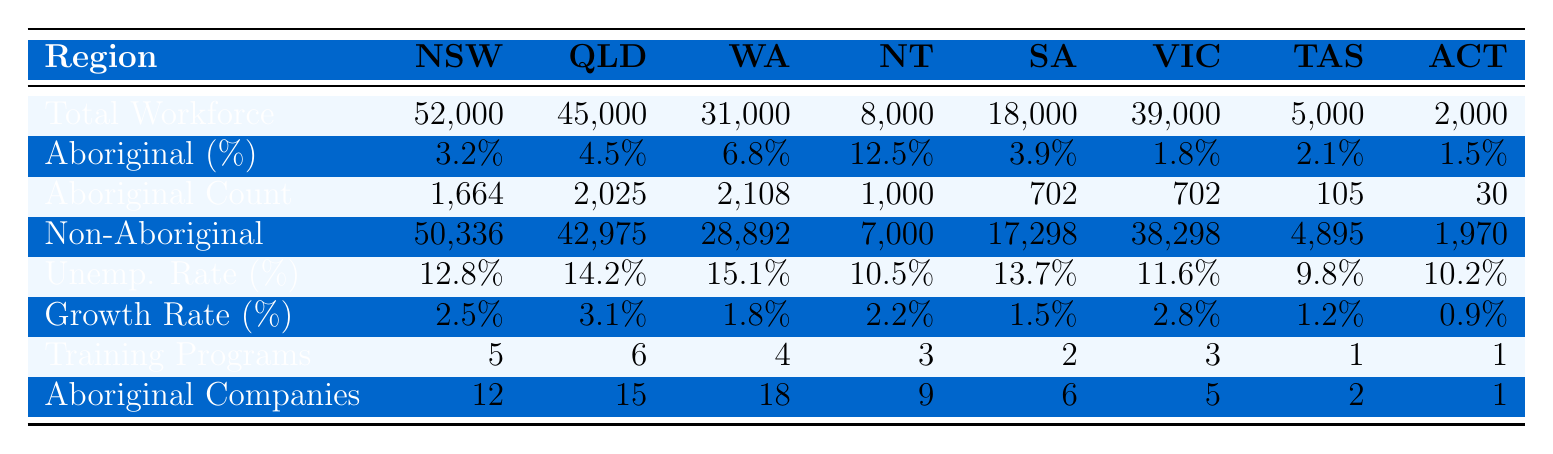What is the total number of Aboriginal truckers in Western Australia? According to the table, the count of Aboriginal truckers in Western Australia is given as 2,108.
Answer: 2,108 Which region has the highest percentage of Aboriginal truckers? The highest percentage of Aboriginal truckers is in the Northern Territory, which is 12.5%.
Answer: Northern Territory What is the total number of truckers in New South Wales? The total trucking workforce in New South Wales is 52,000, as stated in the table.
Answer: 52,000 What is the unemployment rate for Aboriginal truckers in South Australia? The Aboriginal unemployment rate for South Australia is 13.7%, as represented in the table.
Answer: 13.7% How many more non-Aboriginal truckers are there in Queensland compared to Aboriginal truckers? In Queensland, there are 42,975 non-Aboriginal truckers and 2,025 Aboriginal truckers. The difference is 42,975 - 2,025 = 40,950.
Answer: 40,950 What is the average growth rate of the trucking industry across all regions? To find the average growth rate, sum all growth rates: (2.5 + 3.1 + 1.8 + 2.2 + 1.5 + 2.8 + 1.2 + 0.9 = 15.0). Then, divide by the number of regions (8): 15.0 / 8 = 1.875.
Answer: 1.875 True or False: There are more Aboriginal-owned trucking companies in Queensland than in New South Wales. The table shows 15 Aboriginal-owned trucking companies in Queensland and 12 in New South Wales, hence the statement is true.
Answer: True What is the total number of Aboriginal truckers across all regions combined? Summing the Aboriginal truckers count: (1,664 + 2,025 + 2,108 + 1,000 + 702 + 702 + 105 + 30 = 8,836).
Answer: 8,836 Which region has the lowest percentage of Aboriginal truckers? The lowest percentage of Aboriginal truckers is in Victoria, which is 1.8%.
Answer: Victoria Compare the Aboriginal unemployment rates in Queensland and the Northern Territory. Which region has a higher rate? The unemployment rate for Aboriginal truckers in Queensland is 14.2%, and in the Northern Territory, it's 10.5%. Since 14.2% > 10.5%, Queensland has the higher rate.
Answer: Queensland has a higher rate 